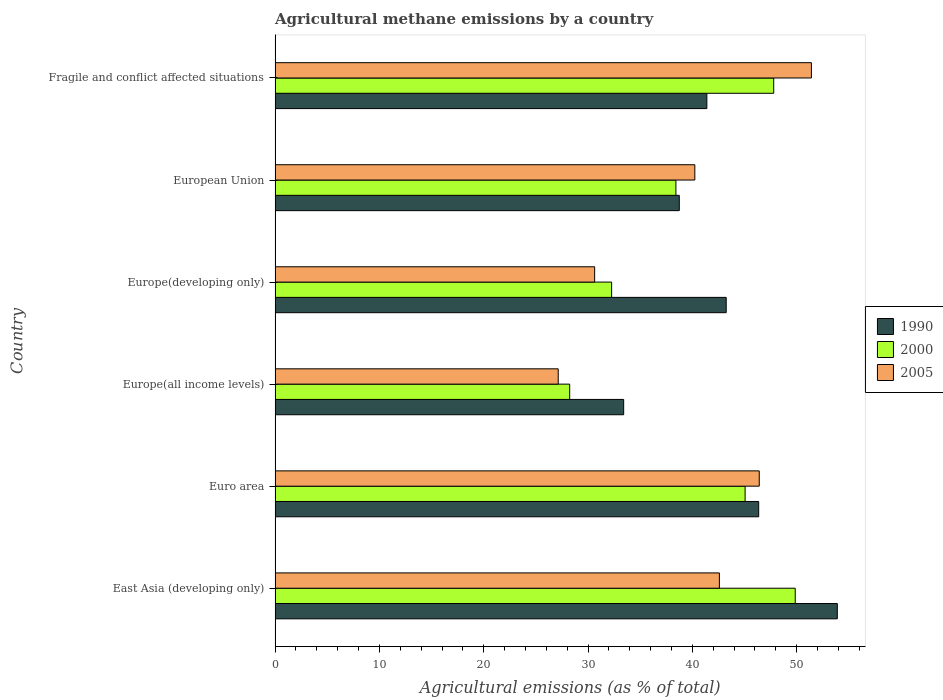How many different coloured bars are there?
Give a very brief answer. 3. How many groups of bars are there?
Make the answer very short. 6. How many bars are there on the 3rd tick from the bottom?
Your answer should be very brief. 3. In how many cases, is the number of bars for a given country not equal to the number of legend labels?
Offer a terse response. 0. What is the amount of agricultural methane emitted in 1990 in Europe(developing only)?
Your answer should be compact. 43.24. Across all countries, what is the maximum amount of agricultural methane emitted in 2000?
Provide a succinct answer. 49.86. Across all countries, what is the minimum amount of agricultural methane emitted in 2000?
Your answer should be very brief. 28.24. In which country was the amount of agricultural methane emitted in 1990 maximum?
Offer a terse response. East Asia (developing only). In which country was the amount of agricultural methane emitted in 2000 minimum?
Offer a very short reply. Europe(all income levels). What is the total amount of agricultural methane emitted in 2005 in the graph?
Make the answer very short. 238.42. What is the difference between the amount of agricultural methane emitted in 2000 in European Union and that in Fragile and conflict affected situations?
Your answer should be very brief. -9.38. What is the difference between the amount of agricultural methane emitted in 2000 in Europe(developing only) and the amount of agricultural methane emitted in 2005 in Europe(all income levels)?
Provide a succinct answer. 5.12. What is the average amount of agricultural methane emitted in 1990 per country?
Ensure brevity in your answer.  42.84. What is the difference between the amount of agricultural methane emitted in 2000 and amount of agricultural methane emitted in 2005 in Europe(all income levels)?
Keep it short and to the point. 1.1. In how many countries, is the amount of agricultural methane emitted in 2005 greater than 10 %?
Provide a succinct answer. 6. What is the ratio of the amount of agricultural methane emitted in 1990 in Europe(developing only) to that in European Union?
Provide a succinct answer. 1.12. Is the difference between the amount of agricultural methane emitted in 2000 in Europe(all income levels) and Fragile and conflict affected situations greater than the difference between the amount of agricultural methane emitted in 2005 in Europe(all income levels) and Fragile and conflict affected situations?
Provide a short and direct response. Yes. What is the difference between the highest and the second highest amount of agricultural methane emitted in 2005?
Provide a succinct answer. 5. What is the difference between the highest and the lowest amount of agricultural methane emitted in 1990?
Keep it short and to the point. 20.48. In how many countries, is the amount of agricultural methane emitted in 1990 greater than the average amount of agricultural methane emitted in 1990 taken over all countries?
Give a very brief answer. 3. What does the 3rd bar from the top in East Asia (developing only) represents?
Your answer should be compact. 1990. Is it the case that in every country, the sum of the amount of agricultural methane emitted in 2005 and amount of agricultural methane emitted in 2000 is greater than the amount of agricultural methane emitted in 1990?
Provide a short and direct response. Yes. Are all the bars in the graph horizontal?
Your answer should be compact. Yes. What is the difference between two consecutive major ticks on the X-axis?
Your response must be concise. 10. Are the values on the major ticks of X-axis written in scientific E-notation?
Provide a short and direct response. No. What is the title of the graph?
Give a very brief answer. Agricultural methane emissions by a country. Does "1980" appear as one of the legend labels in the graph?
Offer a very short reply. No. What is the label or title of the X-axis?
Provide a succinct answer. Agricultural emissions (as % of total). What is the Agricultural emissions (as % of total) of 1990 in East Asia (developing only)?
Ensure brevity in your answer.  53.89. What is the Agricultural emissions (as % of total) of 2000 in East Asia (developing only)?
Your answer should be compact. 49.86. What is the Agricultural emissions (as % of total) in 2005 in East Asia (developing only)?
Provide a short and direct response. 42.59. What is the Agricultural emissions (as % of total) of 1990 in Euro area?
Keep it short and to the point. 46.36. What is the Agricultural emissions (as % of total) of 2000 in Euro area?
Offer a terse response. 45.06. What is the Agricultural emissions (as % of total) of 2005 in Euro area?
Make the answer very short. 46.41. What is the Agricultural emissions (as % of total) of 1990 in Europe(all income levels)?
Offer a terse response. 33.41. What is the Agricultural emissions (as % of total) of 2000 in Europe(all income levels)?
Offer a terse response. 28.24. What is the Agricultural emissions (as % of total) of 2005 in Europe(all income levels)?
Your answer should be compact. 27.14. What is the Agricultural emissions (as % of total) of 1990 in Europe(developing only)?
Your answer should be very brief. 43.24. What is the Agricultural emissions (as % of total) of 2000 in Europe(developing only)?
Your answer should be compact. 32.26. What is the Agricultural emissions (as % of total) in 2005 in Europe(developing only)?
Your answer should be compact. 30.63. What is the Agricultural emissions (as % of total) in 1990 in European Union?
Offer a terse response. 38.75. What is the Agricultural emissions (as % of total) of 2000 in European Union?
Ensure brevity in your answer.  38.42. What is the Agricultural emissions (as % of total) in 2005 in European Union?
Ensure brevity in your answer.  40.24. What is the Agricultural emissions (as % of total) of 1990 in Fragile and conflict affected situations?
Give a very brief answer. 41.39. What is the Agricultural emissions (as % of total) in 2000 in Fragile and conflict affected situations?
Give a very brief answer. 47.8. What is the Agricultural emissions (as % of total) in 2005 in Fragile and conflict affected situations?
Keep it short and to the point. 51.41. Across all countries, what is the maximum Agricultural emissions (as % of total) of 1990?
Your response must be concise. 53.89. Across all countries, what is the maximum Agricultural emissions (as % of total) in 2000?
Your response must be concise. 49.86. Across all countries, what is the maximum Agricultural emissions (as % of total) of 2005?
Offer a terse response. 51.41. Across all countries, what is the minimum Agricultural emissions (as % of total) of 1990?
Your answer should be very brief. 33.41. Across all countries, what is the minimum Agricultural emissions (as % of total) of 2000?
Provide a succinct answer. 28.24. Across all countries, what is the minimum Agricultural emissions (as % of total) in 2005?
Make the answer very short. 27.14. What is the total Agricultural emissions (as % of total) in 1990 in the graph?
Provide a short and direct response. 257.04. What is the total Agricultural emissions (as % of total) in 2000 in the graph?
Make the answer very short. 241.63. What is the total Agricultural emissions (as % of total) in 2005 in the graph?
Your answer should be very brief. 238.42. What is the difference between the Agricultural emissions (as % of total) in 1990 in East Asia (developing only) and that in Euro area?
Offer a very short reply. 7.54. What is the difference between the Agricultural emissions (as % of total) of 2000 in East Asia (developing only) and that in Euro area?
Ensure brevity in your answer.  4.8. What is the difference between the Agricultural emissions (as % of total) of 2005 in East Asia (developing only) and that in Euro area?
Your answer should be very brief. -3.82. What is the difference between the Agricultural emissions (as % of total) in 1990 in East Asia (developing only) and that in Europe(all income levels)?
Your answer should be compact. 20.48. What is the difference between the Agricultural emissions (as % of total) in 2000 in East Asia (developing only) and that in Europe(all income levels)?
Provide a short and direct response. 21.62. What is the difference between the Agricultural emissions (as % of total) of 2005 in East Asia (developing only) and that in Europe(all income levels)?
Ensure brevity in your answer.  15.45. What is the difference between the Agricultural emissions (as % of total) of 1990 in East Asia (developing only) and that in Europe(developing only)?
Provide a short and direct response. 10.65. What is the difference between the Agricultural emissions (as % of total) in 2000 in East Asia (developing only) and that in Europe(developing only)?
Your answer should be compact. 17.6. What is the difference between the Agricultural emissions (as % of total) of 2005 in East Asia (developing only) and that in Europe(developing only)?
Give a very brief answer. 11.96. What is the difference between the Agricultural emissions (as % of total) in 1990 in East Asia (developing only) and that in European Union?
Your answer should be compact. 15.15. What is the difference between the Agricultural emissions (as % of total) in 2000 in East Asia (developing only) and that in European Union?
Ensure brevity in your answer.  11.44. What is the difference between the Agricultural emissions (as % of total) of 2005 in East Asia (developing only) and that in European Union?
Your response must be concise. 2.35. What is the difference between the Agricultural emissions (as % of total) in 1990 in East Asia (developing only) and that in Fragile and conflict affected situations?
Make the answer very short. 12.5. What is the difference between the Agricultural emissions (as % of total) in 2000 in East Asia (developing only) and that in Fragile and conflict affected situations?
Keep it short and to the point. 2.06. What is the difference between the Agricultural emissions (as % of total) of 2005 in East Asia (developing only) and that in Fragile and conflict affected situations?
Your answer should be compact. -8.82. What is the difference between the Agricultural emissions (as % of total) in 1990 in Euro area and that in Europe(all income levels)?
Your answer should be very brief. 12.94. What is the difference between the Agricultural emissions (as % of total) of 2000 in Euro area and that in Europe(all income levels)?
Provide a short and direct response. 16.82. What is the difference between the Agricultural emissions (as % of total) in 2005 in Euro area and that in Europe(all income levels)?
Give a very brief answer. 19.27. What is the difference between the Agricultural emissions (as % of total) of 1990 in Euro area and that in Europe(developing only)?
Make the answer very short. 3.11. What is the difference between the Agricultural emissions (as % of total) of 2000 in Euro area and that in Europe(developing only)?
Offer a very short reply. 12.8. What is the difference between the Agricultural emissions (as % of total) of 2005 in Euro area and that in Europe(developing only)?
Your response must be concise. 15.78. What is the difference between the Agricultural emissions (as % of total) of 1990 in Euro area and that in European Union?
Offer a very short reply. 7.61. What is the difference between the Agricultural emissions (as % of total) in 2000 in Euro area and that in European Union?
Offer a terse response. 6.63. What is the difference between the Agricultural emissions (as % of total) in 2005 in Euro area and that in European Union?
Your answer should be compact. 6.18. What is the difference between the Agricultural emissions (as % of total) in 1990 in Euro area and that in Fragile and conflict affected situations?
Give a very brief answer. 4.97. What is the difference between the Agricultural emissions (as % of total) of 2000 in Euro area and that in Fragile and conflict affected situations?
Offer a terse response. -2.74. What is the difference between the Agricultural emissions (as % of total) of 2005 in Euro area and that in Fragile and conflict affected situations?
Make the answer very short. -5. What is the difference between the Agricultural emissions (as % of total) in 1990 in Europe(all income levels) and that in Europe(developing only)?
Keep it short and to the point. -9.83. What is the difference between the Agricultural emissions (as % of total) of 2000 in Europe(all income levels) and that in Europe(developing only)?
Make the answer very short. -4.02. What is the difference between the Agricultural emissions (as % of total) of 2005 in Europe(all income levels) and that in Europe(developing only)?
Provide a succinct answer. -3.49. What is the difference between the Agricultural emissions (as % of total) of 1990 in Europe(all income levels) and that in European Union?
Your answer should be very brief. -5.33. What is the difference between the Agricultural emissions (as % of total) of 2000 in Europe(all income levels) and that in European Union?
Provide a succinct answer. -10.18. What is the difference between the Agricultural emissions (as % of total) of 2005 in Europe(all income levels) and that in European Union?
Your answer should be very brief. -13.09. What is the difference between the Agricultural emissions (as % of total) of 1990 in Europe(all income levels) and that in Fragile and conflict affected situations?
Provide a succinct answer. -7.98. What is the difference between the Agricultural emissions (as % of total) of 2000 in Europe(all income levels) and that in Fragile and conflict affected situations?
Offer a very short reply. -19.56. What is the difference between the Agricultural emissions (as % of total) in 2005 in Europe(all income levels) and that in Fragile and conflict affected situations?
Your answer should be very brief. -24.27. What is the difference between the Agricultural emissions (as % of total) in 1990 in Europe(developing only) and that in European Union?
Make the answer very short. 4.5. What is the difference between the Agricultural emissions (as % of total) in 2000 in Europe(developing only) and that in European Union?
Your answer should be compact. -6.16. What is the difference between the Agricultural emissions (as % of total) in 2005 in Europe(developing only) and that in European Union?
Your answer should be very brief. -9.6. What is the difference between the Agricultural emissions (as % of total) of 1990 in Europe(developing only) and that in Fragile and conflict affected situations?
Provide a short and direct response. 1.85. What is the difference between the Agricultural emissions (as % of total) of 2000 in Europe(developing only) and that in Fragile and conflict affected situations?
Offer a terse response. -15.54. What is the difference between the Agricultural emissions (as % of total) of 2005 in Europe(developing only) and that in Fragile and conflict affected situations?
Offer a very short reply. -20.78. What is the difference between the Agricultural emissions (as % of total) of 1990 in European Union and that in Fragile and conflict affected situations?
Make the answer very short. -2.64. What is the difference between the Agricultural emissions (as % of total) of 2000 in European Union and that in Fragile and conflict affected situations?
Provide a short and direct response. -9.38. What is the difference between the Agricultural emissions (as % of total) in 2005 in European Union and that in Fragile and conflict affected situations?
Make the answer very short. -11.17. What is the difference between the Agricultural emissions (as % of total) of 1990 in East Asia (developing only) and the Agricultural emissions (as % of total) of 2000 in Euro area?
Provide a succinct answer. 8.84. What is the difference between the Agricultural emissions (as % of total) in 1990 in East Asia (developing only) and the Agricultural emissions (as % of total) in 2005 in Euro area?
Provide a short and direct response. 7.48. What is the difference between the Agricultural emissions (as % of total) of 2000 in East Asia (developing only) and the Agricultural emissions (as % of total) of 2005 in Euro area?
Your response must be concise. 3.45. What is the difference between the Agricultural emissions (as % of total) of 1990 in East Asia (developing only) and the Agricultural emissions (as % of total) of 2000 in Europe(all income levels)?
Offer a very short reply. 25.65. What is the difference between the Agricultural emissions (as % of total) in 1990 in East Asia (developing only) and the Agricultural emissions (as % of total) in 2005 in Europe(all income levels)?
Your response must be concise. 26.75. What is the difference between the Agricultural emissions (as % of total) of 2000 in East Asia (developing only) and the Agricultural emissions (as % of total) of 2005 in Europe(all income levels)?
Your answer should be very brief. 22.72. What is the difference between the Agricultural emissions (as % of total) of 1990 in East Asia (developing only) and the Agricultural emissions (as % of total) of 2000 in Europe(developing only)?
Provide a succinct answer. 21.63. What is the difference between the Agricultural emissions (as % of total) of 1990 in East Asia (developing only) and the Agricultural emissions (as % of total) of 2005 in Europe(developing only)?
Give a very brief answer. 23.26. What is the difference between the Agricultural emissions (as % of total) of 2000 in East Asia (developing only) and the Agricultural emissions (as % of total) of 2005 in Europe(developing only)?
Offer a very short reply. 19.23. What is the difference between the Agricultural emissions (as % of total) of 1990 in East Asia (developing only) and the Agricultural emissions (as % of total) of 2000 in European Union?
Your response must be concise. 15.47. What is the difference between the Agricultural emissions (as % of total) in 1990 in East Asia (developing only) and the Agricultural emissions (as % of total) in 2005 in European Union?
Offer a terse response. 13.66. What is the difference between the Agricultural emissions (as % of total) in 2000 in East Asia (developing only) and the Agricultural emissions (as % of total) in 2005 in European Union?
Keep it short and to the point. 9.62. What is the difference between the Agricultural emissions (as % of total) of 1990 in East Asia (developing only) and the Agricultural emissions (as % of total) of 2000 in Fragile and conflict affected situations?
Offer a terse response. 6.1. What is the difference between the Agricultural emissions (as % of total) of 1990 in East Asia (developing only) and the Agricultural emissions (as % of total) of 2005 in Fragile and conflict affected situations?
Your response must be concise. 2.48. What is the difference between the Agricultural emissions (as % of total) of 2000 in East Asia (developing only) and the Agricultural emissions (as % of total) of 2005 in Fragile and conflict affected situations?
Offer a very short reply. -1.55. What is the difference between the Agricultural emissions (as % of total) of 1990 in Euro area and the Agricultural emissions (as % of total) of 2000 in Europe(all income levels)?
Offer a terse response. 18.12. What is the difference between the Agricultural emissions (as % of total) of 1990 in Euro area and the Agricultural emissions (as % of total) of 2005 in Europe(all income levels)?
Your answer should be very brief. 19.22. What is the difference between the Agricultural emissions (as % of total) in 2000 in Euro area and the Agricultural emissions (as % of total) in 2005 in Europe(all income levels)?
Make the answer very short. 17.91. What is the difference between the Agricultural emissions (as % of total) of 1990 in Euro area and the Agricultural emissions (as % of total) of 2000 in Europe(developing only)?
Keep it short and to the point. 14.1. What is the difference between the Agricultural emissions (as % of total) of 1990 in Euro area and the Agricultural emissions (as % of total) of 2005 in Europe(developing only)?
Ensure brevity in your answer.  15.73. What is the difference between the Agricultural emissions (as % of total) of 2000 in Euro area and the Agricultural emissions (as % of total) of 2005 in Europe(developing only)?
Your answer should be very brief. 14.42. What is the difference between the Agricultural emissions (as % of total) in 1990 in Euro area and the Agricultural emissions (as % of total) in 2000 in European Union?
Your answer should be compact. 7.94. What is the difference between the Agricultural emissions (as % of total) in 1990 in Euro area and the Agricultural emissions (as % of total) in 2005 in European Union?
Provide a short and direct response. 6.12. What is the difference between the Agricultural emissions (as % of total) of 2000 in Euro area and the Agricultural emissions (as % of total) of 2005 in European Union?
Offer a terse response. 4.82. What is the difference between the Agricultural emissions (as % of total) of 1990 in Euro area and the Agricultural emissions (as % of total) of 2000 in Fragile and conflict affected situations?
Keep it short and to the point. -1.44. What is the difference between the Agricultural emissions (as % of total) of 1990 in Euro area and the Agricultural emissions (as % of total) of 2005 in Fragile and conflict affected situations?
Make the answer very short. -5.05. What is the difference between the Agricultural emissions (as % of total) in 2000 in Euro area and the Agricultural emissions (as % of total) in 2005 in Fragile and conflict affected situations?
Give a very brief answer. -6.35. What is the difference between the Agricultural emissions (as % of total) in 1990 in Europe(all income levels) and the Agricultural emissions (as % of total) in 2000 in Europe(developing only)?
Make the answer very short. 1.15. What is the difference between the Agricultural emissions (as % of total) in 1990 in Europe(all income levels) and the Agricultural emissions (as % of total) in 2005 in Europe(developing only)?
Provide a short and direct response. 2.78. What is the difference between the Agricultural emissions (as % of total) of 2000 in Europe(all income levels) and the Agricultural emissions (as % of total) of 2005 in Europe(developing only)?
Give a very brief answer. -2.39. What is the difference between the Agricultural emissions (as % of total) of 1990 in Europe(all income levels) and the Agricultural emissions (as % of total) of 2000 in European Union?
Your answer should be compact. -5.01. What is the difference between the Agricultural emissions (as % of total) of 1990 in Europe(all income levels) and the Agricultural emissions (as % of total) of 2005 in European Union?
Keep it short and to the point. -6.82. What is the difference between the Agricultural emissions (as % of total) of 2000 in Europe(all income levels) and the Agricultural emissions (as % of total) of 2005 in European Union?
Offer a very short reply. -12. What is the difference between the Agricultural emissions (as % of total) in 1990 in Europe(all income levels) and the Agricultural emissions (as % of total) in 2000 in Fragile and conflict affected situations?
Your response must be concise. -14.38. What is the difference between the Agricultural emissions (as % of total) of 1990 in Europe(all income levels) and the Agricultural emissions (as % of total) of 2005 in Fragile and conflict affected situations?
Give a very brief answer. -18. What is the difference between the Agricultural emissions (as % of total) of 2000 in Europe(all income levels) and the Agricultural emissions (as % of total) of 2005 in Fragile and conflict affected situations?
Ensure brevity in your answer.  -23.17. What is the difference between the Agricultural emissions (as % of total) in 1990 in Europe(developing only) and the Agricultural emissions (as % of total) in 2000 in European Union?
Your answer should be compact. 4.82. What is the difference between the Agricultural emissions (as % of total) of 1990 in Europe(developing only) and the Agricultural emissions (as % of total) of 2005 in European Union?
Your response must be concise. 3.01. What is the difference between the Agricultural emissions (as % of total) of 2000 in Europe(developing only) and the Agricultural emissions (as % of total) of 2005 in European Union?
Offer a very short reply. -7.98. What is the difference between the Agricultural emissions (as % of total) of 1990 in Europe(developing only) and the Agricultural emissions (as % of total) of 2000 in Fragile and conflict affected situations?
Your answer should be compact. -4.55. What is the difference between the Agricultural emissions (as % of total) of 1990 in Europe(developing only) and the Agricultural emissions (as % of total) of 2005 in Fragile and conflict affected situations?
Ensure brevity in your answer.  -8.17. What is the difference between the Agricultural emissions (as % of total) in 2000 in Europe(developing only) and the Agricultural emissions (as % of total) in 2005 in Fragile and conflict affected situations?
Provide a short and direct response. -19.15. What is the difference between the Agricultural emissions (as % of total) in 1990 in European Union and the Agricultural emissions (as % of total) in 2000 in Fragile and conflict affected situations?
Give a very brief answer. -9.05. What is the difference between the Agricultural emissions (as % of total) of 1990 in European Union and the Agricultural emissions (as % of total) of 2005 in Fragile and conflict affected situations?
Offer a very short reply. -12.66. What is the difference between the Agricultural emissions (as % of total) in 2000 in European Union and the Agricultural emissions (as % of total) in 2005 in Fragile and conflict affected situations?
Provide a short and direct response. -12.99. What is the average Agricultural emissions (as % of total) in 1990 per country?
Keep it short and to the point. 42.84. What is the average Agricultural emissions (as % of total) of 2000 per country?
Your answer should be very brief. 40.27. What is the average Agricultural emissions (as % of total) of 2005 per country?
Offer a very short reply. 39.74. What is the difference between the Agricultural emissions (as % of total) in 1990 and Agricultural emissions (as % of total) in 2000 in East Asia (developing only)?
Offer a very short reply. 4.03. What is the difference between the Agricultural emissions (as % of total) of 1990 and Agricultural emissions (as % of total) of 2005 in East Asia (developing only)?
Ensure brevity in your answer.  11.3. What is the difference between the Agricultural emissions (as % of total) of 2000 and Agricultural emissions (as % of total) of 2005 in East Asia (developing only)?
Provide a succinct answer. 7.27. What is the difference between the Agricultural emissions (as % of total) of 1990 and Agricultural emissions (as % of total) of 2000 in Euro area?
Give a very brief answer. 1.3. What is the difference between the Agricultural emissions (as % of total) in 1990 and Agricultural emissions (as % of total) in 2005 in Euro area?
Your answer should be compact. -0.05. What is the difference between the Agricultural emissions (as % of total) of 2000 and Agricultural emissions (as % of total) of 2005 in Euro area?
Your response must be concise. -1.36. What is the difference between the Agricultural emissions (as % of total) of 1990 and Agricultural emissions (as % of total) of 2000 in Europe(all income levels)?
Provide a short and direct response. 5.17. What is the difference between the Agricultural emissions (as % of total) of 1990 and Agricultural emissions (as % of total) of 2005 in Europe(all income levels)?
Offer a very short reply. 6.27. What is the difference between the Agricultural emissions (as % of total) in 2000 and Agricultural emissions (as % of total) in 2005 in Europe(all income levels)?
Your response must be concise. 1.1. What is the difference between the Agricultural emissions (as % of total) in 1990 and Agricultural emissions (as % of total) in 2000 in Europe(developing only)?
Provide a short and direct response. 10.98. What is the difference between the Agricultural emissions (as % of total) of 1990 and Agricultural emissions (as % of total) of 2005 in Europe(developing only)?
Your response must be concise. 12.61. What is the difference between the Agricultural emissions (as % of total) of 2000 and Agricultural emissions (as % of total) of 2005 in Europe(developing only)?
Ensure brevity in your answer.  1.63. What is the difference between the Agricultural emissions (as % of total) of 1990 and Agricultural emissions (as % of total) of 2000 in European Union?
Offer a very short reply. 0.32. What is the difference between the Agricultural emissions (as % of total) in 1990 and Agricultural emissions (as % of total) in 2005 in European Union?
Ensure brevity in your answer.  -1.49. What is the difference between the Agricultural emissions (as % of total) in 2000 and Agricultural emissions (as % of total) in 2005 in European Union?
Make the answer very short. -1.81. What is the difference between the Agricultural emissions (as % of total) in 1990 and Agricultural emissions (as % of total) in 2000 in Fragile and conflict affected situations?
Offer a very short reply. -6.41. What is the difference between the Agricultural emissions (as % of total) of 1990 and Agricultural emissions (as % of total) of 2005 in Fragile and conflict affected situations?
Offer a terse response. -10.02. What is the difference between the Agricultural emissions (as % of total) in 2000 and Agricultural emissions (as % of total) in 2005 in Fragile and conflict affected situations?
Make the answer very short. -3.61. What is the ratio of the Agricultural emissions (as % of total) in 1990 in East Asia (developing only) to that in Euro area?
Your response must be concise. 1.16. What is the ratio of the Agricultural emissions (as % of total) of 2000 in East Asia (developing only) to that in Euro area?
Offer a very short reply. 1.11. What is the ratio of the Agricultural emissions (as % of total) in 2005 in East Asia (developing only) to that in Euro area?
Your answer should be very brief. 0.92. What is the ratio of the Agricultural emissions (as % of total) of 1990 in East Asia (developing only) to that in Europe(all income levels)?
Keep it short and to the point. 1.61. What is the ratio of the Agricultural emissions (as % of total) of 2000 in East Asia (developing only) to that in Europe(all income levels)?
Keep it short and to the point. 1.77. What is the ratio of the Agricultural emissions (as % of total) in 2005 in East Asia (developing only) to that in Europe(all income levels)?
Keep it short and to the point. 1.57. What is the ratio of the Agricultural emissions (as % of total) of 1990 in East Asia (developing only) to that in Europe(developing only)?
Give a very brief answer. 1.25. What is the ratio of the Agricultural emissions (as % of total) in 2000 in East Asia (developing only) to that in Europe(developing only)?
Provide a succinct answer. 1.55. What is the ratio of the Agricultural emissions (as % of total) in 2005 in East Asia (developing only) to that in Europe(developing only)?
Give a very brief answer. 1.39. What is the ratio of the Agricultural emissions (as % of total) in 1990 in East Asia (developing only) to that in European Union?
Your response must be concise. 1.39. What is the ratio of the Agricultural emissions (as % of total) in 2000 in East Asia (developing only) to that in European Union?
Offer a very short reply. 1.3. What is the ratio of the Agricultural emissions (as % of total) of 2005 in East Asia (developing only) to that in European Union?
Ensure brevity in your answer.  1.06. What is the ratio of the Agricultural emissions (as % of total) in 1990 in East Asia (developing only) to that in Fragile and conflict affected situations?
Make the answer very short. 1.3. What is the ratio of the Agricultural emissions (as % of total) in 2000 in East Asia (developing only) to that in Fragile and conflict affected situations?
Keep it short and to the point. 1.04. What is the ratio of the Agricultural emissions (as % of total) in 2005 in East Asia (developing only) to that in Fragile and conflict affected situations?
Keep it short and to the point. 0.83. What is the ratio of the Agricultural emissions (as % of total) in 1990 in Euro area to that in Europe(all income levels)?
Provide a short and direct response. 1.39. What is the ratio of the Agricultural emissions (as % of total) in 2000 in Euro area to that in Europe(all income levels)?
Offer a terse response. 1.6. What is the ratio of the Agricultural emissions (as % of total) of 2005 in Euro area to that in Europe(all income levels)?
Your answer should be compact. 1.71. What is the ratio of the Agricultural emissions (as % of total) of 1990 in Euro area to that in Europe(developing only)?
Your response must be concise. 1.07. What is the ratio of the Agricultural emissions (as % of total) of 2000 in Euro area to that in Europe(developing only)?
Provide a succinct answer. 1.4. What is the ratio of the Agricultural emissions (as % of total) of 2005 in Euro area to that in Europe(developing only)?
Provide a succinct answer. 1.52. What is the ratio of the Agricultural emissions (as % of total) of 1990 in Euro area to that in European Union?
Give a very brief answer. 1.2. What is the ratio of the Agricultural emissions (as % of total) of 2000 in Euro area to that in European Union?
Provide a short and direct response. 1.17. What is the ratio of the Agricultural emissions (as % of total) in 2005 in Euro area to that in European Union?
Offer a terse response. 1.15. What is the ratio of the Agricultural emissions (as % of total) of 1990 in Euro area to that in Fragile and conflict affected situations?
Offer a terse response. 1.12. What is the ratio of the Agricultural emissions (as % of total) of 2000 in Euro area to that in Fragile and conflict affected situations?
Provide a short and direct response. 0.94. What is the ratio of the Agricultural emissions (as % of total) in 2005 in Euro area to that in Fragile and conflict affected situations?
Offer a terse response. 0.9. What is the ratio of the Agricultural emissions (as % of total) in 1990 in Europe(all income levels) to that in Europe(developing only)?
Make the answer very short. 0.77. What is the ratio of the Agricultural emissions (as % of total) of 2000 in Europe(all income levels) to that in Europe(developing only)?
Provide a short and direct response. 0.88. What is the ratio of the Agricultural emissions (as % of total) in 2005 in Europe(all income levels) to that in Europe(developing only)?
Make the answer very short. 0.89. What is the ratio of the Agricultural emissions (as % of total) of 1990 in Europe(all income levels) to that in European Union?
Your answer should be compact. 0.86. What is the ratio of the Agricultural emissions (as % of total) in 2000 in Europe(all income levels) to that in European Union?
Give a very brief answer. 0.73. What is the ratio of the Agricultural emissions (as % of total) in 2005 in Europe(all income levels) to that in European Union?
Provide a short and direct response. 0.67. What is the ratio of the Agricultural emissions (as % of total) of 1990 in Europe(all income levels) to that in Fragile and conflict affected situations?
Your response must be concise. 0.81. What is the ratio of the Agricultural emissions (as % of total) of 2000 in Europe(all income levels) to that in Fragile and conflict affected situations?
Keep it short and to the point. 0.59. What is the ratio of the Agricultural emissions (as % of total) in 2005 in Europe(all income levels) to that in Fragile and conflict affected situations?
Offer a very short reply. 0.53. What is the ratio of the Agricultural emissions (as % of total) of 1990 in Europe(developing only) to that in European Union?
Your answer should be compact. 1.12. What is the ratio of the Agricultural emissions (as % of total) in 2000 in Europe(developing only) to that in European Union?
Provide a short and direct response. 0.84. What is the ratio of the Agricultural emissions (as % of total) in 2005 in Europe(developing only) to that in European Union?
Give a very brief answer. 0.76. What is the ratio of the Agricultural emissions (as % of total) in 1990 in Europe(developing only) to that in Fragile and conflict affected situations?
Your answer should be very brief. 1.04. What is the ratio of the Agricultural emissions (as % of total) of 2000 in Europe(developing only) to that in Fragile and conflict affected situations?
Your answer should be very brief. 0.67. What is the ratio of the Agricultural emissions (as % of total) of 2005 in Europe(developing only) to that in Fragile and conflict affected situations?
Your response must be concise. 0.6. What is the ratio of the Agricultural emissions (as % of total) of 1990 in European Union to that in Fragile and conflict affected situations?
Ensure brevity in your answer.  0.94. What is the ratio of the Agricultural emissions (as % of total) of 2000 in European Union to that in Fragile and conflict affected situations?
Offer a very short reply. 0.8. What is the ratio of the Agricultural emissions (as % of total) in 2005 in European Union to that in Fragile and conflict affected situations?
Ensure brevity in your answer.  0.78. What is the difference between the highest and the second highest Agricultural emissions (as % of total) of 1990?
Your answer should be very brief. 7.54. What is the difference between the highest and the second highest Agricultural emissions (as % of total) in 2000?
Provide a succinct answer. 2.06. What is the difference between the highest and the second highest Agricultural emissions (as % of total) of 2005?
Your response must be concise. 5. What is the difference between the highest and the lowest Agricultural emissions (as % of total) in 1990?
Offer a very short reply. 20.48. What is the difference between the highest and the lowest Agricultural emissions (as % of total) of 2000?
Provide a succinct answer. 21.62. What is the difference between the highest and the lowest Agricultural emissions (as % of total) of 2005?
Your answer should be compact. 24.27. 